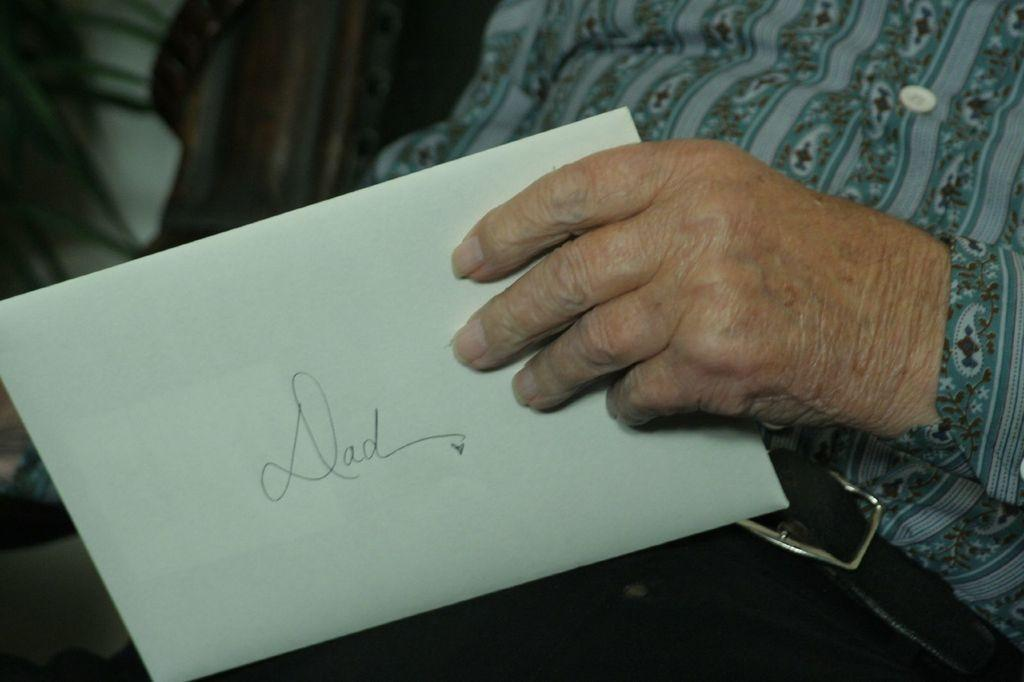What is the person in the image doing? There is a person sitting in the image. What is the person holding in his hand? The person is holding a letter in his hand. What type of gun is the person holding in the image? There is no gun present in the image; the person is holding a letter. What view can be seen from the person's perspective in the image? The facts provided do not give any information about the view or perspective in the image. 